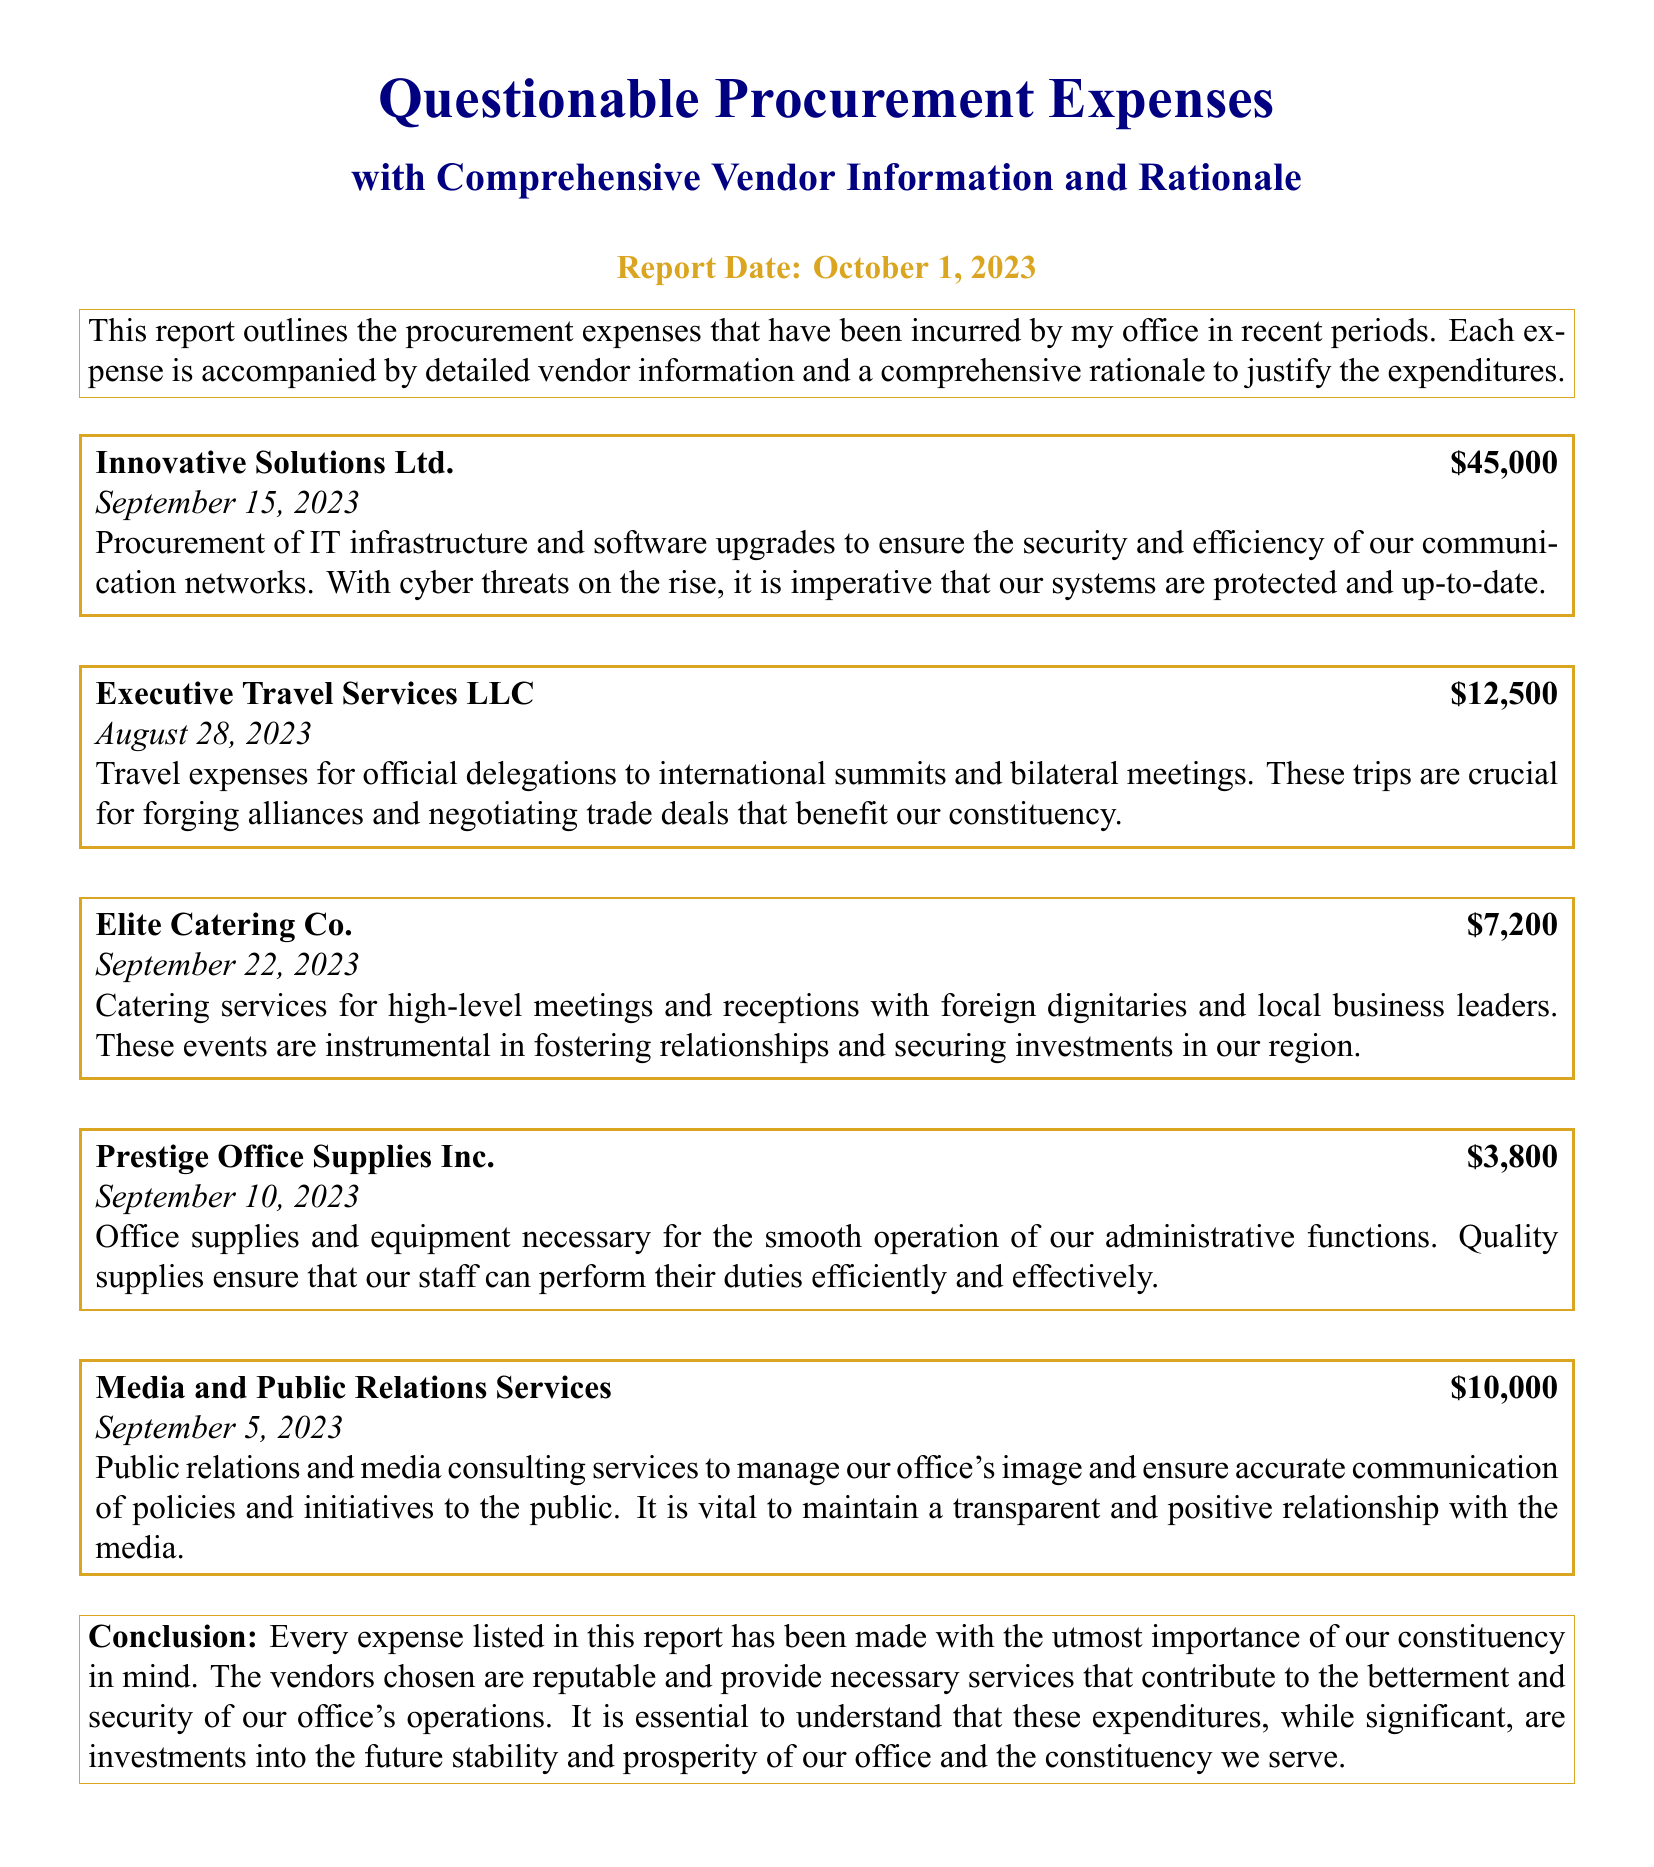What is the total amount spent on Innovative Solutions Ltd.? The amount spent on Innovative Solutions Ltd. is specifically listed in the document as $45,000.
Answer: $45,000 What date was the expense for Executive Travel Services LLC incurred? The document states that the expense for Executive Travel Services LLC was incurred on August 28, 2023.
Answer: August 28, 2023 What is the purpose of the expenses for Elite Catering Co.? The purpose of the expenses is mentioned as catering services for high-level meetings and receptions with dignitaries and business leaders.
Answer: Catering services for high-level meetings and receptions How much was allocated for public relations and media consulting services? The document lists the amount allocated for these services as $10,000.
Answer: $10,000 What is the rationale behind the procurement of IT infrastructure? The rationale is to ensure the security and efficiency of communication networks against rising cyber threats.
Answer: Security and efficiency of communication networks What is the total spending on all expenses listed in the report? To determine the total, sum the expenses: $45,000 + $12,500 + $7,200 + $3,800 + $10,000 = $78,500.
Answer: $78,500 What is the date of the report? The report date is clearly stated as October 1, 2023.
Answer: October 1, 2023 What kind of services does Prestige Office Supplies Inc. provide? Prestige Office Supplies Inc. provides office supplies and equipment necessary for administrative functions.
Answer: Office supplies and equipment What significance do the trips mentioned in the document have for the constituency? The trips are crucial for forging alliances and negotiating trade deals that benefit the constituency.
Answer: Forging alliances and negotiating trade deals 